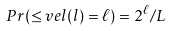Convert formula to latex. <formula><loc_0><loc_0><loc_500><loc_500>P r ( \leq v e l ( l ) = \ell ) = 2 ^ { \ell } / L</formula> 